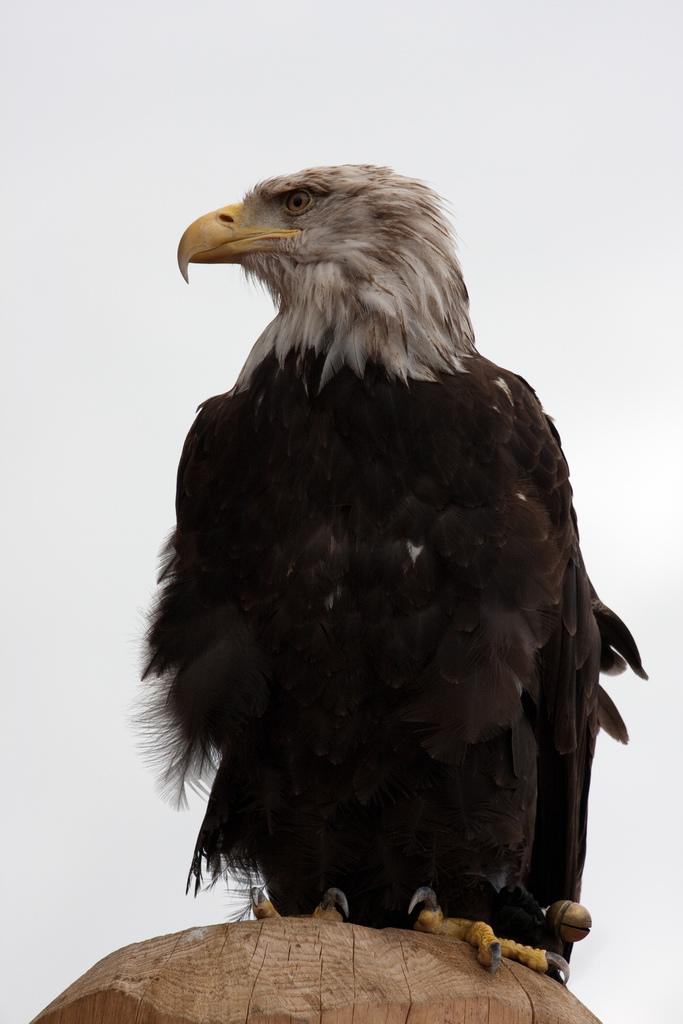What type of animal is in the image? There is a bird in the image. What is the bird standing on? The bird is on a wooden surface. Where is the bird located in the image? The bird is in the center of the image. What type of toothbrush is the bird using in the image? There is no toothbrush present in the image, and the bird is not using any apparatus. 